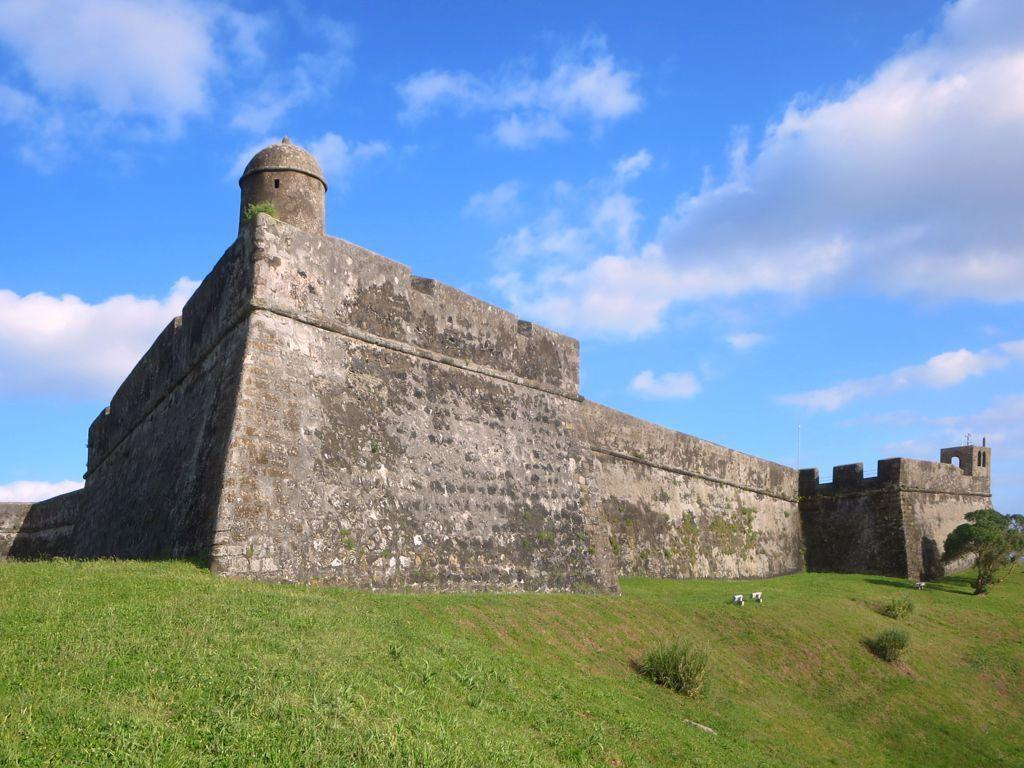Where was the picture taken? The picture was taken outside. What is the main subject in the center of the image? There is a castle in the center of the image. What is the ground covered with? The ground is covered with green grass. What other natural elements can be seen in the image? There are plants visible in the image. What can be seen in the background of the image? The sky is visible in the background of the image. What type of rifle is being used by the person standing next to the castle in the image? There is no person or rifle present in the image; it features a castle and natural elements. 